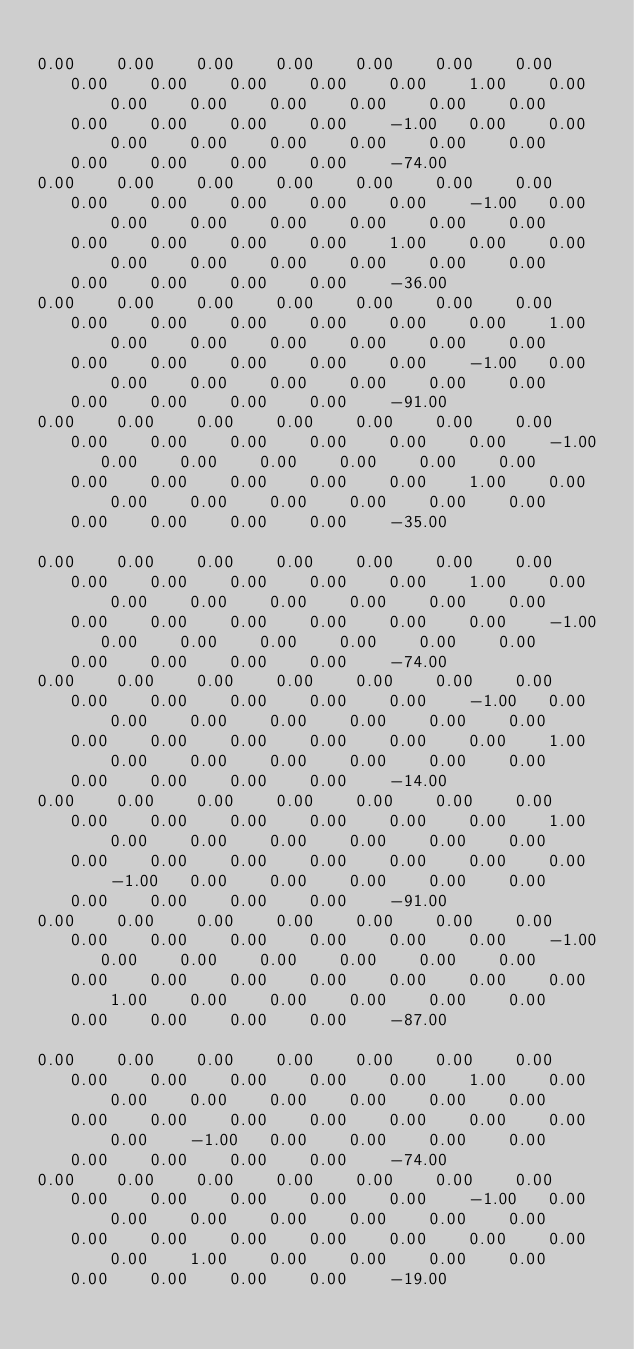Convert code to text. <code><loc_0><loc_0><loc_500><loc_500><_Matlab_>
0.00	0.00	0.00	0.00	0.00	0.00	0.00	0.00	0.00	0.00	0.00	0.00	1.00	0.00	0.00	0.00	0.00	0.00	0.00	0.00	0.00	0.00	0.00	0.00	-1.00	0.00	0.00	0.00	0.00	0.00	0.00	0.00	0.00	0.00	0.00	0.00	0.00	-74.00
0.00	0.00	0.00	0.00	0.00	0.00	0.00	0.00	0.00	0.00	0.00	0.00	-1.00	0.00	0.00	0.00	0.00	0.00	0.00	0.00	0.00	0.00	0.00	0.00	1.00	0.00	0.00	0.00	0.00	0.00	0.00	0.00	0.00	0.00	0.00	0.00	0.00	-36.00
0.00	0.00	0.00	0.00	0.00	0.00	0.00	0.00	0.00	0.00	0.00	0.00	0.00	1.00	0.00	0.00	0.00	0.00	0.00	0.00	0.00	0.00	0.00	0.00	0.00	-1.00	0.00	0.00	0.00	0.00	0.00	0.00	0.00	0.00	0.00	0.00	0.00	-91.00
0.00	0.00	0.00	0.00	0.00	0.00	0.00	0.00	0.00	0.00	0.00	0.00	0.00	-1.00	0.00	0.00	0.00	0.00	0.00	0.00	0.00	0.00	0.00	0.00	0.00	1.00	0.00	0.00	0.00	0.00	0.00	0.00	0.00	0.00	0.00	0.00	0.00	-35.00

0.00	0.00	0.00	0.00	0.00	0.00	0.00	0.00	0.00	0.00	0.00	0.00	1.00	0.00	0.00	0.00	0.00	0.00	0.00	0.00	0.00	0.00	0.00	0.00	0.00	0.00	-1.00	0.00	0.00	0.00	0.00	0.00	0.00	0.00	0.00	0.00	0.00	-74.00
0.00	0.00	0.00	0.00	0.00	0.00	0.00	0.00	0.00	0.00	0.00	0.00	-1.00	0.00	0.00	0.00	0.00	0.00	0.00	0.00	0.00	0.00	0.00	0.00	0.00	0.00	1.00	0.00	0.00	0.00	0.00	0.00	0.00	0.00	0.00	0.00	0.00	-14.00
0.00	0.00	0.00	0.00	0.00	0.00	0.00	0.00	0.00	0.00	0.00	0.00	0.00	1.00	0.00	0.00	0.00	0.00	0.00	0.00	0.00	0.00	0.00	0.00	0.00	0.00	0.00	-1.00	0.00	0.00	0.00	0.00	0.00	0.00	0.00	0.00	0.00	-91.00
0.00	0.00	0.00	0.00	0.00	0.00	0.00	0.00	0.00	0.00	0.00	0.00	0.00	-1.00	0.00	0.00	0.00	0.00	0.00	0.00	0.00	0.00	0.00	0.00	0.00	0.00	0.00	1.00	0.00	0.00	0.00	0.00	0.00	0.00	0.00	0.00	0.00	-87.00

0.00	0.00	0.00	0.00	0.00	0.00	0.00	0.00	0.00	0.00	0.00	0.00	1.00	0.00	0.00	0.00	0.00	0.00	0.00	0.00	0.00	0.00	0.00	0.00	0.00	0.00	0.00	0.00	-1.00	0.00	0.00	0.00	0.00	0.00	0.00	0.00	0.00	-74.00
0.00	0.00	0.00	0.00	0.00	0.00	0.00	0.00	0.00	0.00	0.00	0.00	-1.00	0.00	0.00	0.00	0.00	0.00	0.00	0.00	0.00	0.00	0.00	0.00	0.00	0.00	0.00	0.00	1.00	0.00	0.00	0.00	0.00	0.00	0.00	0.00	0.00	-19.00</code> 